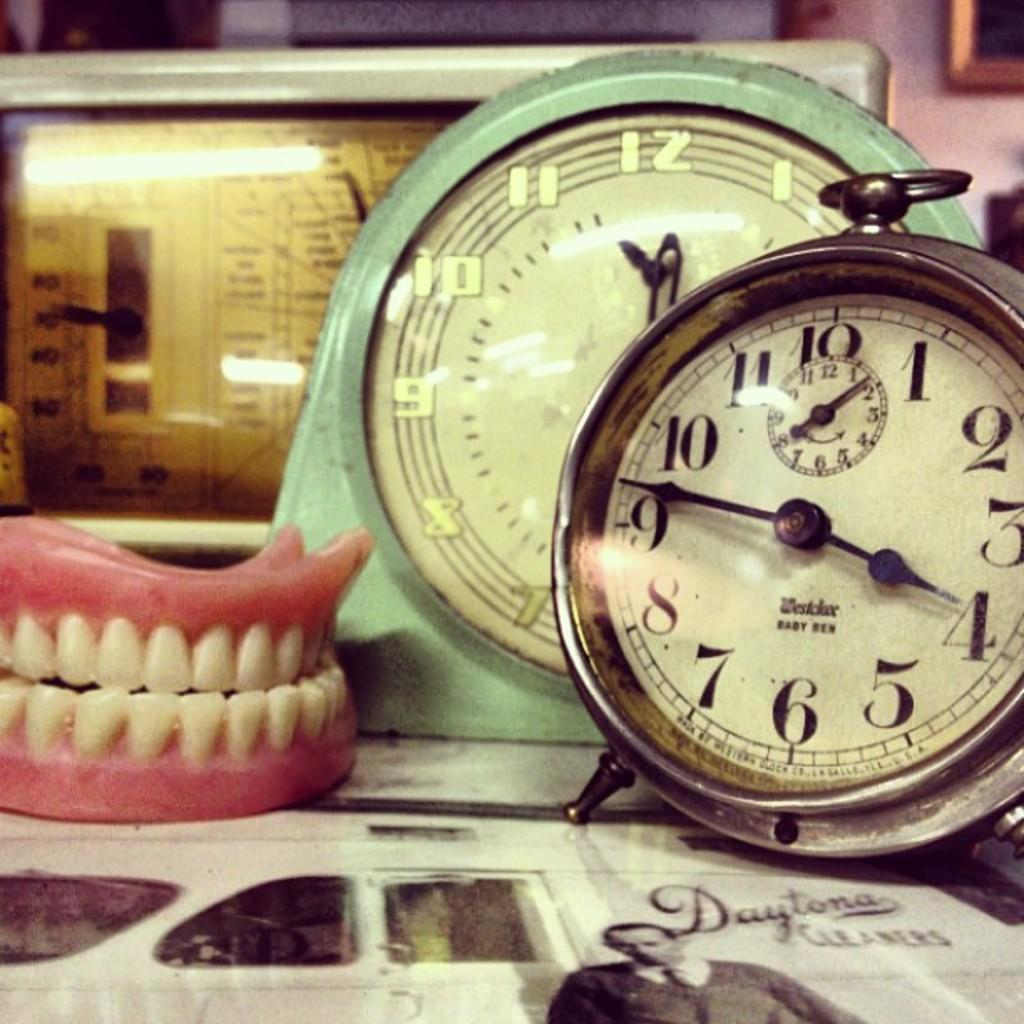<image>
Present a compact description of the photo's key features. A Daytona Cleaners paper with dentures and two clocks on top of it. 